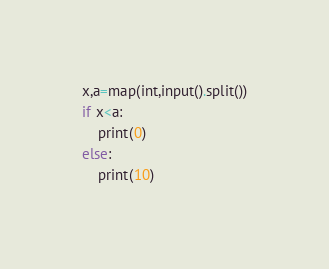<code> <loc_0><loc_0><loc_500><loc_500><_Python_>x,a=map(int,input().split())
if x<a:
    print(0)
else:
    print(10)</code> 